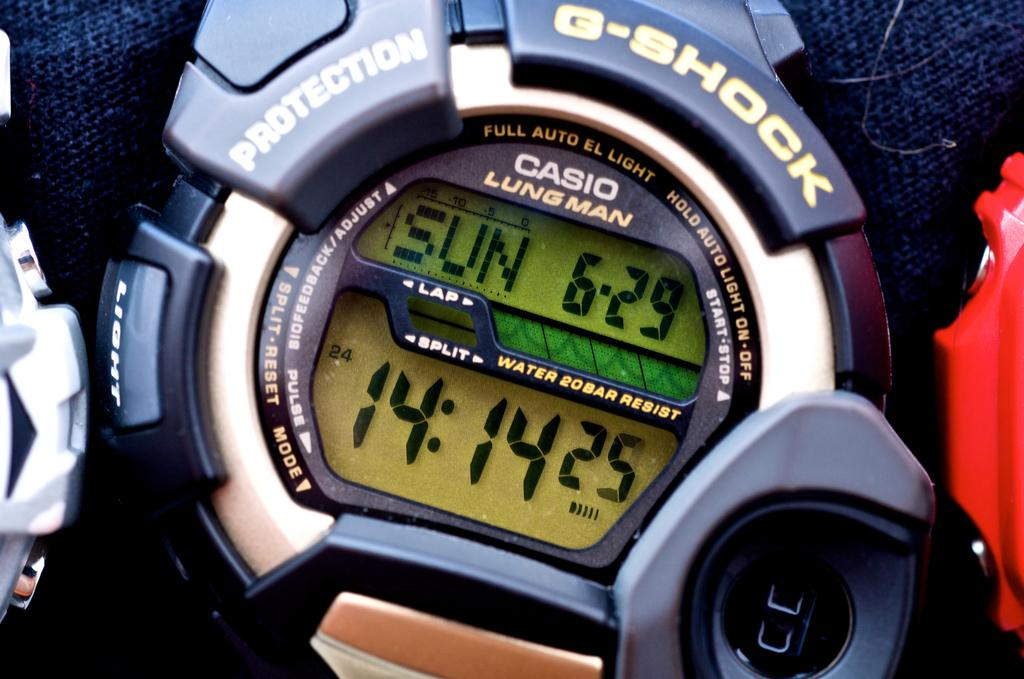<image>
Offer a succinct explanation of the picture presented. A Casio Lung Man watch has the time of 14:14. 